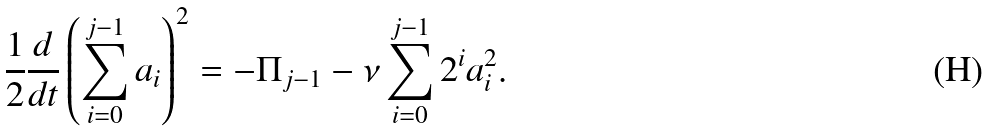Convert formula to latex. <formula><loc_0><loc_0><loc_500><loc_500>\frac { 1 } { 2 } \frac { d } { d t } \left ( \sum _ { i = 0 } ^ { j - 1 } a _ { i } \right ) ^ { 2 } = - \Pi _ { j - 1 } - \nu \sum _ { i = 0 } ^ { j - 1 } 2 ^ { i } a _ { i } ^ { 2 } .</formula> 